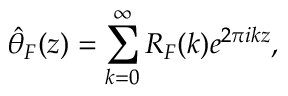<formula> <loc_0><loc_0><loc_500><loc_500>{ \hat { \theta } } _ { F } ( z ) = \sum _ { k = 0 } ^ { \infty } R _ { F } ( k ) e ^ { 2 \pi i k z } ,</formula> 